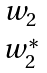Convert formula to latex. <formula><loc_0><loc_0><loc_500><loc_500>\begin{matrix} w _ { 2 } \\ w ^ { * } _ { 2 } \end{matrix}</formula> 